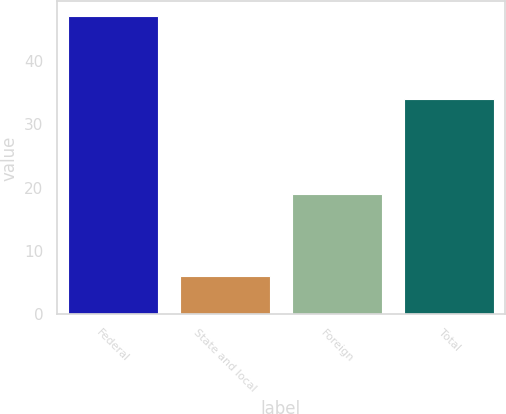Convert chart to OTSL. <chart><loc_0><loc_0><loc_500><loc_500><bar_chart><fcel>Federal<fcel>State and local<fcel>Foreign<fcel>Total<nl><fcel>47<fcel>6<fcel>19<fcel>34<nl></chart> 